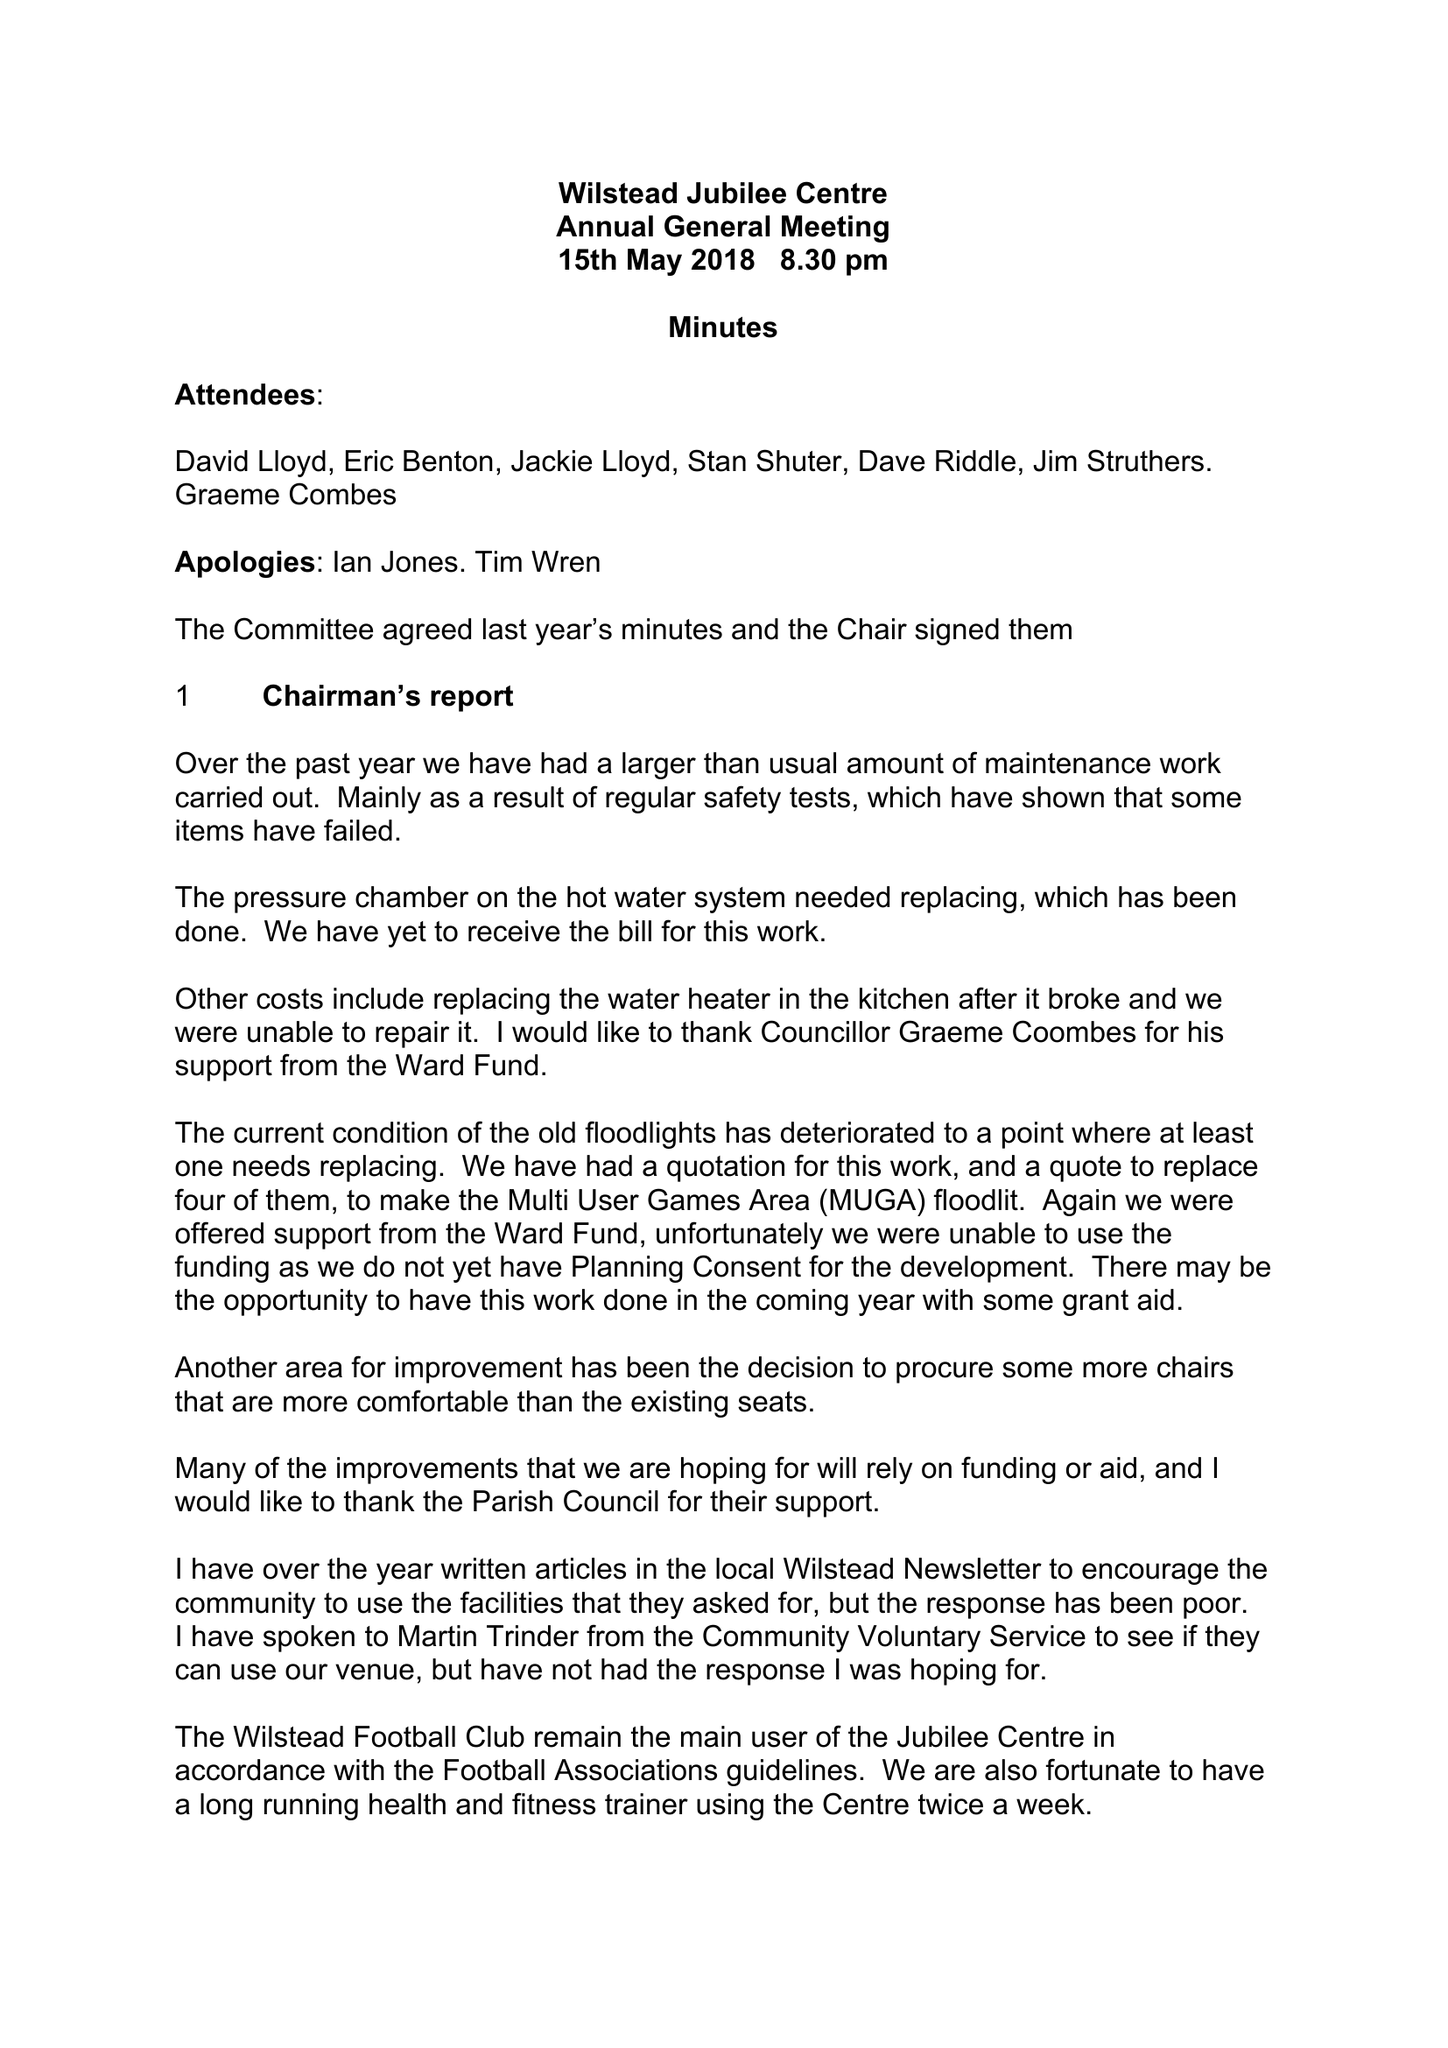What is the value for the income_annually_in_british_pounds?
Answer the question using a single word or phrase. 4530.00 